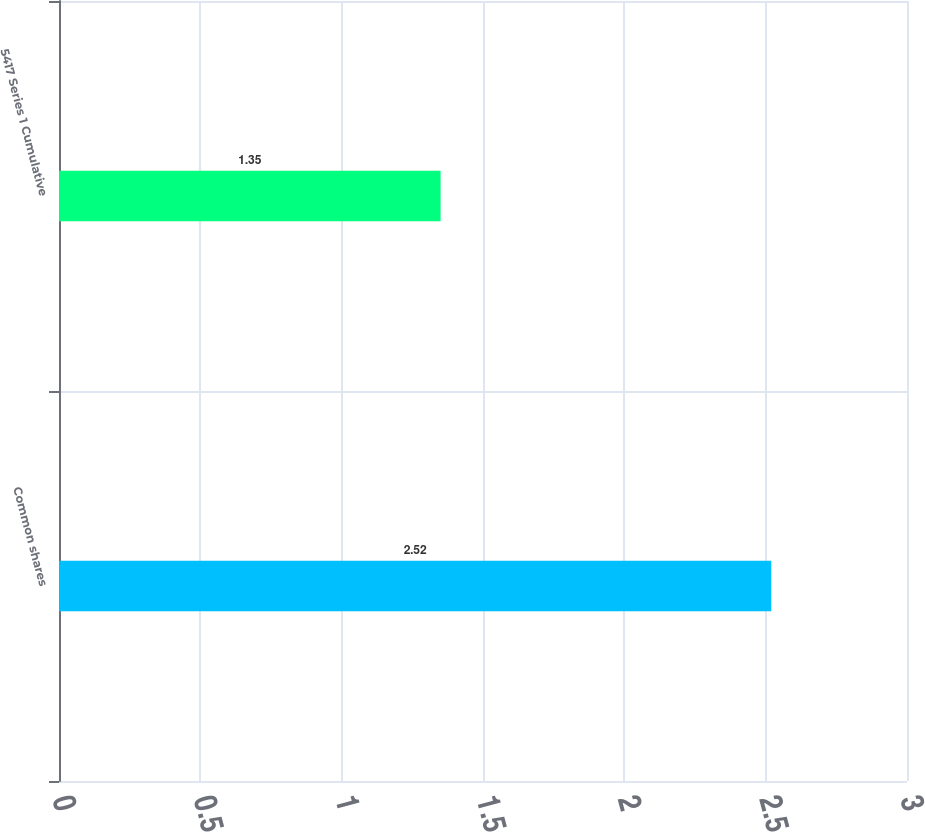<chart> <loc_0><loc_0><loc_500><loc_500><bar_chart><fcel>Common shares<fcel>5417 Series 1 Cumulative<nl><fcel>2.52<fcel>1.35<nl></chart> 